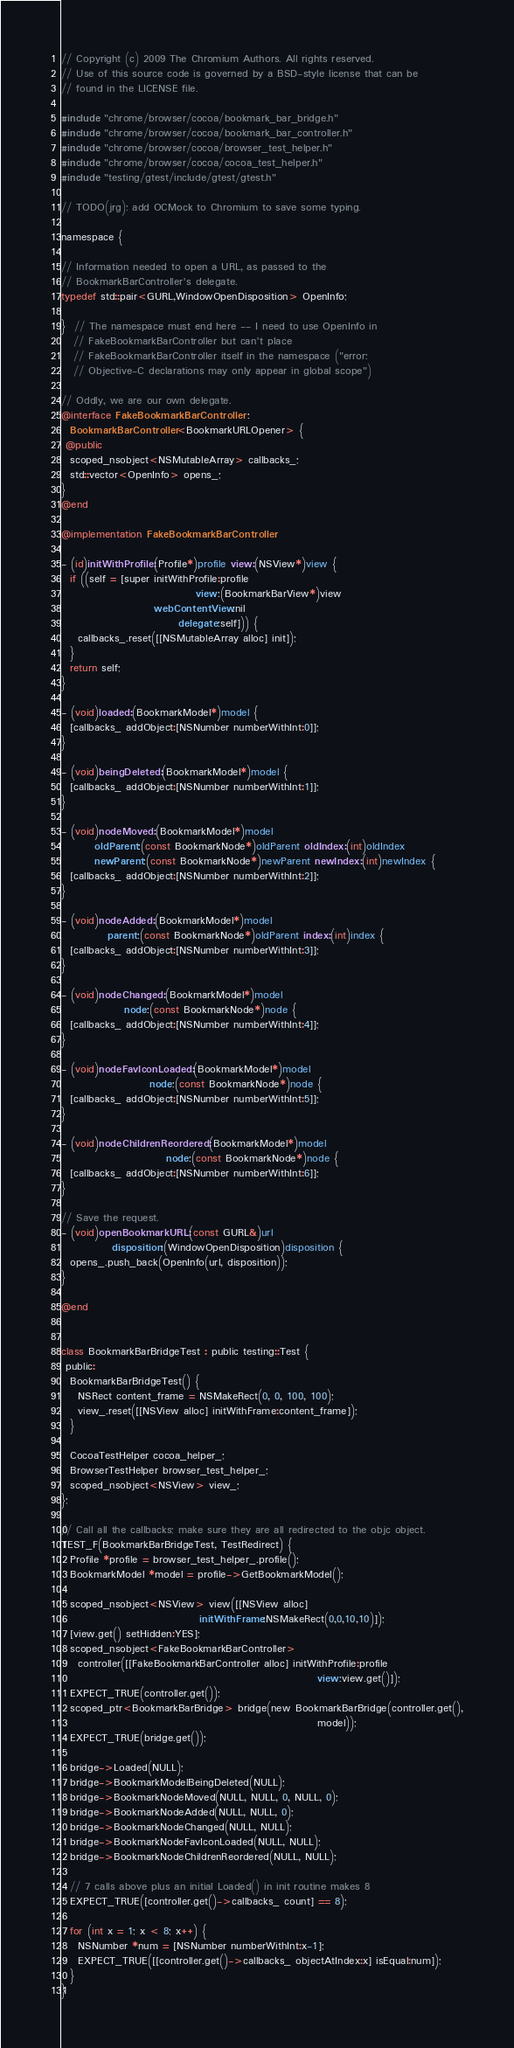<code> <loc_0><loc_0><loc_500><loc_500><_ObjectiveC_>// Copyright (c) 2009 The Chromium Authors. All rights reserved.
// Use of this source code is governed by a BSD-style license that can be
// found in the LICENSE file.

#include "chrome/browser/cocoa/bookmark_bar_bridge.h"
#include "chrome/browser/cocoa/bookmark_bar_controller.h"
#include "chrome/browser/cocoa/browser_test_helper.h"
#include "chrome/browser/cocoa/cocoa_test_helper.h"
#include "testing/gtest/include/gtest/gtest.h"

// TODO(jrg): add OCMock to Chromium to save some typing.

namespace {

// Information needed to open a URL, as passed to the
// BookmarkBarController's delegate.
typedef std::pair<GURL,WindowOpenDisposition> OpenInfo;

}  // The namespace must end here -- I need to use OpenInfo in
   // FakeBookmarkBarController but can't place
   // FakeBookmarkBarController itself in the namespace ("error:
   // Objective-C declarations may only appear in global scope")

// Oddly, we are our own delegate.
@interface FakeBookmarkBarController :
  BookmarkBarController<BookmarkURLOpener> {
 @public
  scoped_nsobject<NSMutableArray> callbacks_;
  std::vector<OpenInfo> opens_;
}
@end

@implementation FakeBookmarkBarController

- (id)initWithProfile:(Profile*)profile view:(NSView*)view {
  if ((self = [super initWithProfile:profile
                                view:(BookmarkBarView*)view
                      webContentView:nil
                            delegate:self])) {
    callbacks_.reset([[NSMutableArray alloc] init]);
  }
  return self;
}

- (void)loaded:(BookmarkModel*)model {
  [callbacks_ addObject:[NSNumber numberWithInt:0]];
}

- (void)beingDeleted:(BookmarkModel*)model {
  [callbacks_ addObject:[NSNumber numberWithInt:1]];
}

- (void)nodeMoved:(BookmarkModel*)model
        oldParent:(const BookmarkNode*)oldParent oldIndex:(int)oldIndex
        newParent:(const BookmarkNode*)newParent newIndex:(int)newIndex {
  [callbacks_ addObject:[NSNumber numberWithInt:2]];
}

- (void)nodeAdded:(BookmarkModel*)model
           parent:(const BookmarkNode*)oldParent index:(int)index {
  [callbacks_ addObject:[NSNumber numberWithInt:3]];
}

- (void)nodeChanged:(BookmarkModel*)model
               node:(const BookmarkNode*)node {
  [callbacks_ addObject:[NSNumber numberWithInt:4]];
}

- (void)nodeFavIconLoaded:(BookmarkModel*)model
                     node:(const BookmarkNode*)node {
  [callbacks_ addObject:[NSNumber numberWithInt:5]];
}

- (void)nodeChildrenReordered:(BookmarkModel*)model
                         node:(const BookmarkNode*)node {
  [callbacks_ addObject:[NSNumber numberWithInt:6]];
}

// Save the request.
- (void)openBookmarkURL:(const GURL&)url
            disposition:(WindowOpenDisposition)disposition {
  opens_.push_back(OpenInfo(url, disposition));
}

@end


class BookmarkBarBridgeTest : public testing::Test {
 public:
  BookmarkBarBridgeTest() {
    NSRect content_frame = NSMakeRect(0, 0, 100, 100);
    view_.reset([[NSView alloc] initWithFrame:content_frame]);
  }

  CocoaTestHelper cocoa_helper_;
  BrowserTestHelper browser_test_helper_;
  scoped_nsobject<NSView> view_;
};

// Call all the callbacks; make sure they are all redirected to the objc object.
TEST_F(BookmarkBarBridgeTest, TestRedirect) {
  Profile *profile = browser_test_helper_.profile();
  BookmarkModel *model = profile->GetBookmarkModel();

  scoped_nsobject<NSView> view([[NSView alloc]
                                 initWithFrame:NSMakeRect(0,0,10,10)]);
  [view.get() setHidden:YES];
  scoped_nsobject<FakeBookmarkBarController>
    controller([[FakeBookmarkBarController alloc] initWithProfile:profile
                                                             view:view.get()]);
  EXPECT_TRUE(controller.get());
  scoped_ptr<BookmarkBarBridge> bridge(new BookmarkBarBridge(controller.get(),
                                                             model));
  EXPECT_TRUE(bridge.get());

  bridge->Loaded(NULL);
  bridge->BookmarkModelBeingDeleted(NULL);
  bridge->BookmarkNodeMoved(NULL, NULL, 0, NULL, 0);
  bridge->BookmarkNodeAdded(NULL, NULL, 0);
  bridge->BookmarkNodeChanged(NULL, NULL);
  bridge->BookmarkNodeFavIconLoaded(NULL, NULL);
  bridge->BookmarkNodeChildrenReordered(NULL, NULL);

  // 7 calls above plus an initial Loaded() in init routine makes 8
  EXPECT_TRUE([controller.get()->callbacks_ count] == 8);

  for (int x = 1; x < 8; x++) {
    NSNumber *num = [NSNumber numberWithInt:x-1];
    EXPECT_TRUE([[controller.get()->callbacks_ objectAtIndex:x] isEqual:num]);
  }
}
</code> 